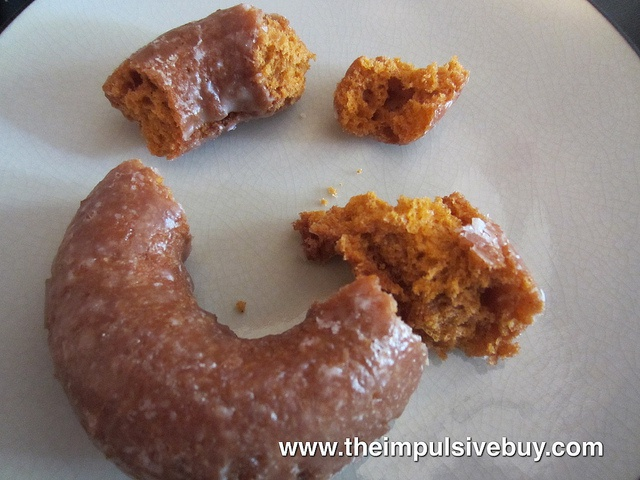Describe the objects in this image and their specific colors. I can see donut in black, maroon, and brown tones, donut in black, maroon, brown, and salmon tones, donut in black, maroon, and brown tones, and donut in black, brown, maroon, and tan tones in this image. 